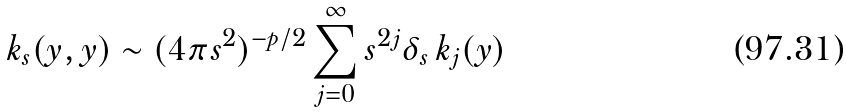Convert formula to latex. <formula><loc_0><loc_0><loc_500><loc_500>k _ { s } ( y , y ) \sim ( 4 \pi s ^ { 2 } ) ^ { - p / 2 } \sum _ { j = 0 } ^ { \infty } s ^ { 2 j } \delta _ { s } \, k _ { j } ( y )</formula> 